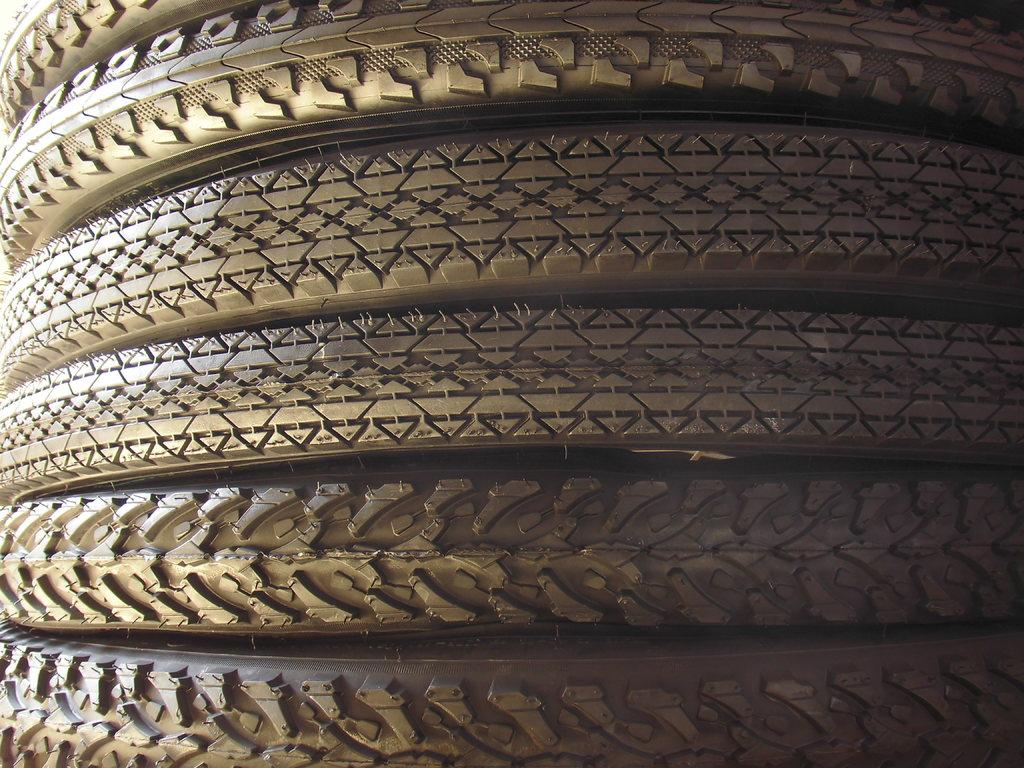What objects are present in the image? There are tires in the image. What distinguishing feature can be observed on the tires? The tires have different tracks. What type of creature is leaving the tracks on the tires in the image? There is no creature present in the image; the tracks on the tires are likely from a vehicle. What story is being told through the tracks on the tires in the image? There is no story being told through the tracks on the tires in the image; they are simply a visual detail of the tires. 